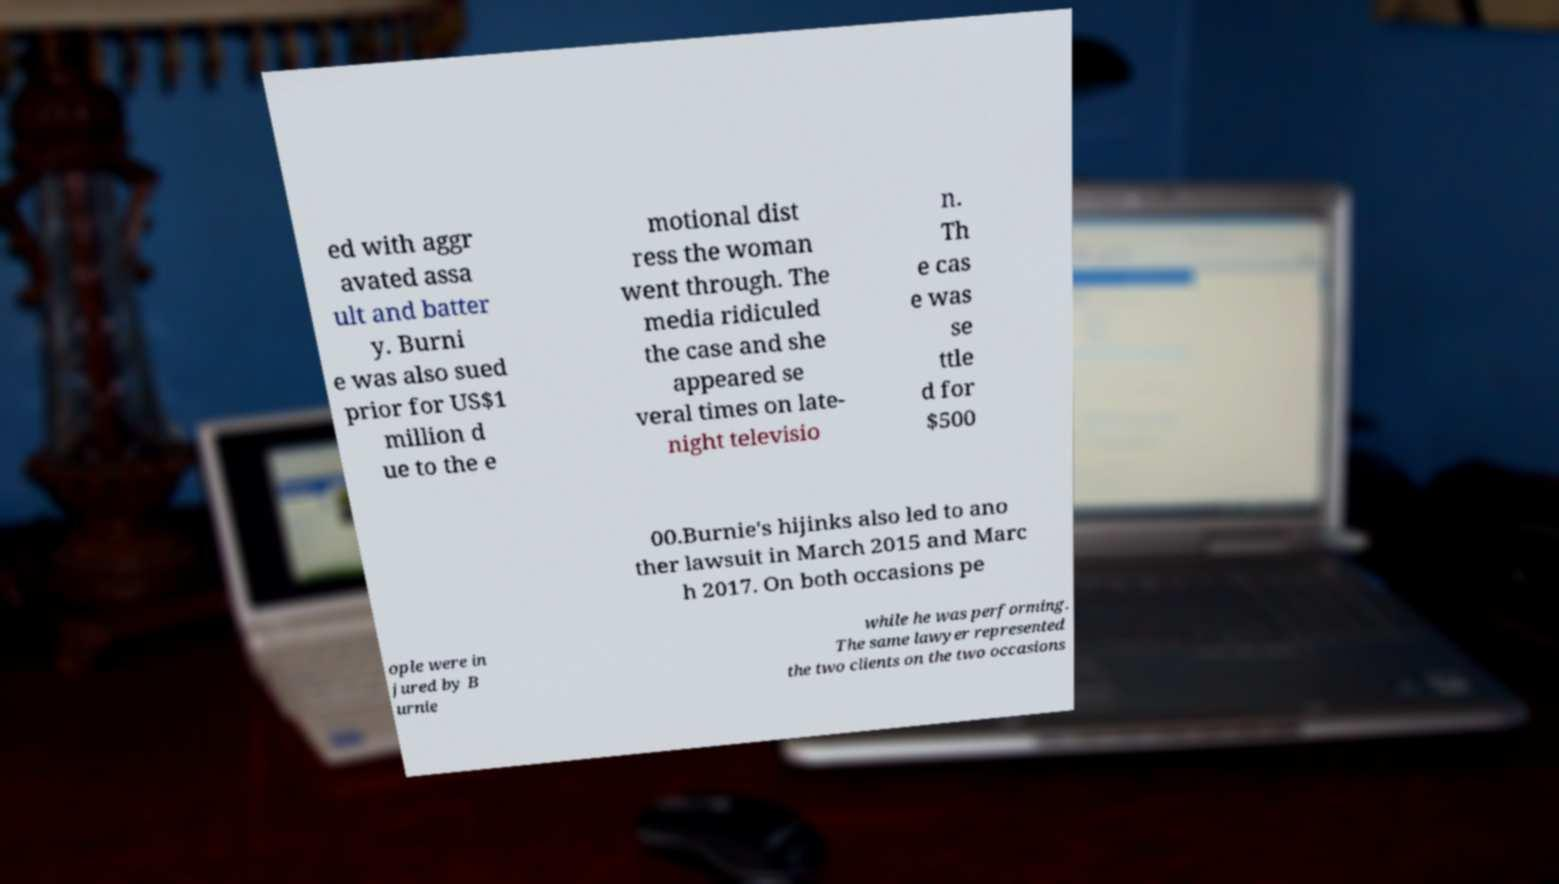There's text embedded in this image that I need extracted. Can you transcribe it verbatim? ed with aggr avated assa ult and batter y. Burni e was also sued prior for US$1 million d ue to the e motional dist ress the woman went through. The media ridiculed the case and she appeared se veral times on late- night televisio n. Th e cas e was se ttle d for $500 00.Burnie's hijinks also led to ano ther lawsuit in March 2015 and Marc h 2017. On both occasions pe ople were in jured by B urnie while he was performing. The same lawyer represented the two clients on the two occasions 